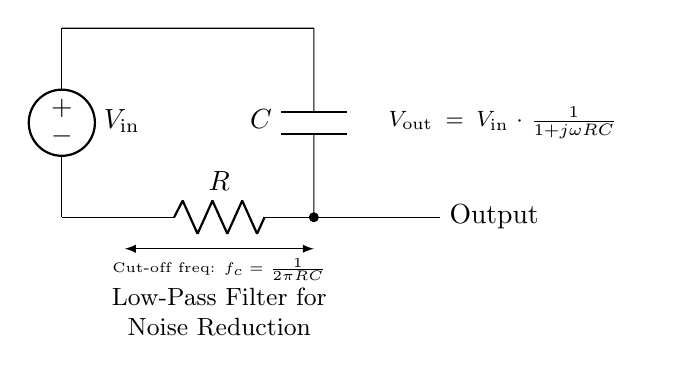What is the type of filter represented in the circuit? The circuit is a low-pass filter, which allows signals with a frequency lower than a certain cut-off frequency to pass through while attenuating higher frequencies. The presence of a resistor and capacitor in configuration indicates this behavior.
Answer: low-pass filter What is the output of the circuit labeled as? The output is labeled as "Output" in the circuit diagram, indicating where the filtered signal can be observed.
Answer: Output What is the cut-off frequency formula in this circuit? The cut-off frequency formula is given beside the circuit diagram as "f_c = 1/(2πRC)". This formula relates the cut-off frequency to the resistance and capacitance in the circuit.
Answer: f_c = 1/(2πRC) What components are used in this low-pass filter? The components used are a resistor and a capacitor. This is standard for low-pass filters where both components are needed to achieve the desired filtering effect.
Answer: Resistor, Capacitor If the resistance is doubled, what happens to the cut-off frequency? If the resistance is doubled, according to the formula f_c = 1/(2πRC), the cut-off frequency will be halved since the resistance is in the denominator and is now twice as large. This decreases the frequency at which the filter begins to attenuate signals.
Answer: Halved What is the relationship between input voltage and output voltage in this circuit? The output voltage (V_out) is defined as a function of the input voltage (V_in) by the equation V_out = V_in * (1/(1 + jωRC)). This shows that the output voltage is dependent on the dynamic interaction between the input voltage and the combined reactance of the capacitor and resistance.
Answer: V_out = V_in * (1/(1 + jωRC)) At high frequencies, what happens to the output voltage? At high frequencies, as ω increases, the term 1 + jωRC becomes dominated by jωRC, causing output voltage to approach zero. This behavior confirms the function of the low-pass filter: to attenuate high-frequency signals.
Answer: Approaches zero 